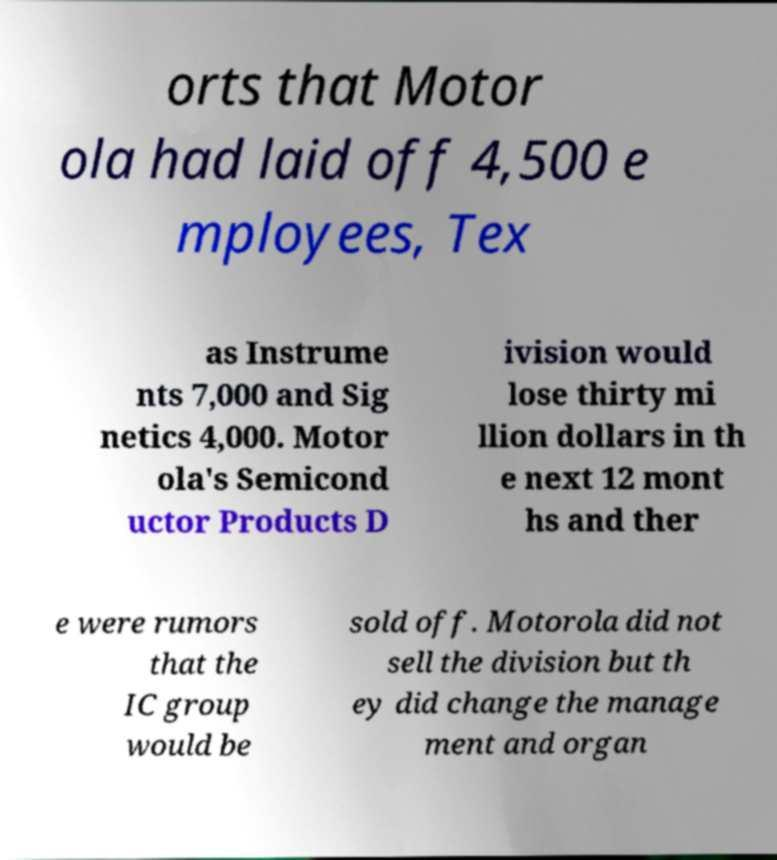Please identify and transcribe the text found in this image. orts that Motor ola had laid off 4,500 e mployees, Tex as Instrume nts 7,000 and Sig netics 4,000. Motor ola's Semicond uctor Products D ivision would lose thirty mi llion dollars in th e next 12 mont hs and ther e were rumors that the IC group would be sold off. Motorola did not sell the division but th ey did change the manage ment and organ 